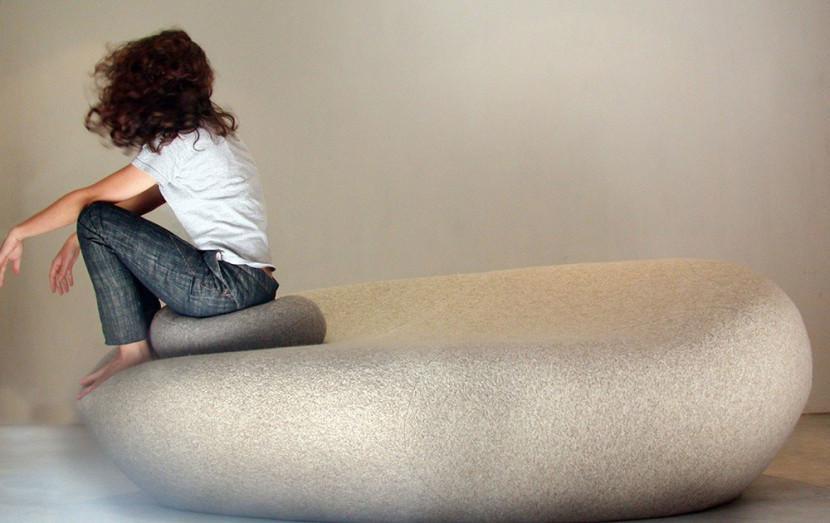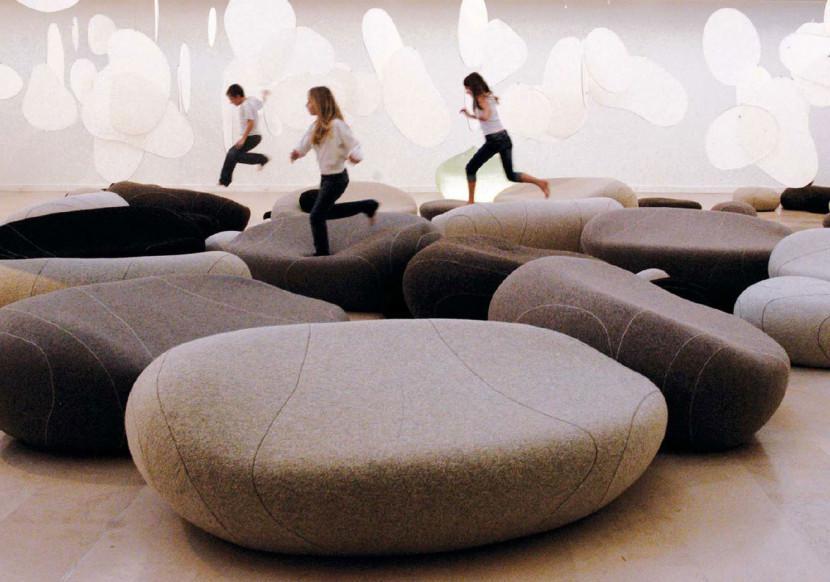The first image is the image on the left, the second image is the image on the right. Analyze the images presented: Is the assertion "In one of the images there is just one person lying in bed with multiple pillows." valid? Answer yes or no. No. 